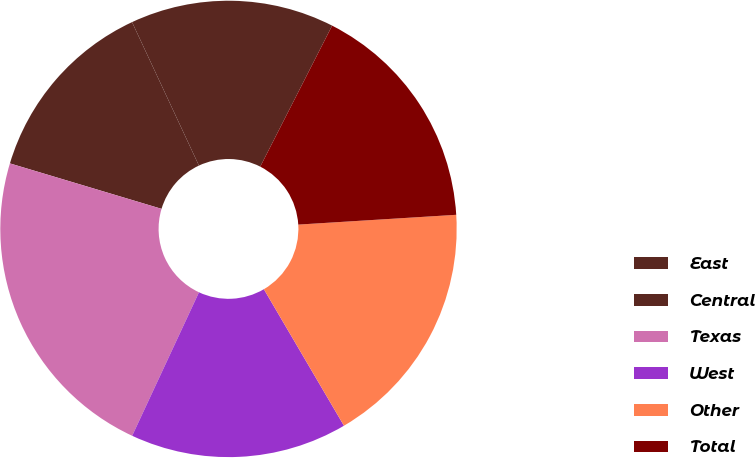Convert chart. <chart><loc_0><loc_0><loc_500><loc_500><pie_chart><fcel>East<fcel>Central<fcel>Texas<fcel>West<fcel>Other<fcel>Total<nl><fcel>14.45%<fcel>13.42%<fcel>22.7%<fcel>15.38%<fcel>17.54%<fcel>16.51%<nl></chart> 